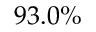<formula> <loc_0><loc_0><loc_500><loc_500>9 3 . 0 \%</formula> 